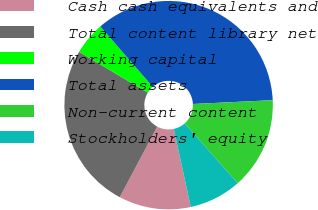<chart> <loc_0><loc_0><loc_500><loc_500><pie_chart><fcel>Cash cash equivalents and<fcel>Total content library net<fcel>Working capital<fcel>Total assets<fcel>Non-current content<fcel>Stockholders' equity<nl><fcel>11.18%<fcel>25.79%<fcel>5.07%<fcel>35.61%<fcel>14.23%<fcel>8.12%<nl></chart> 